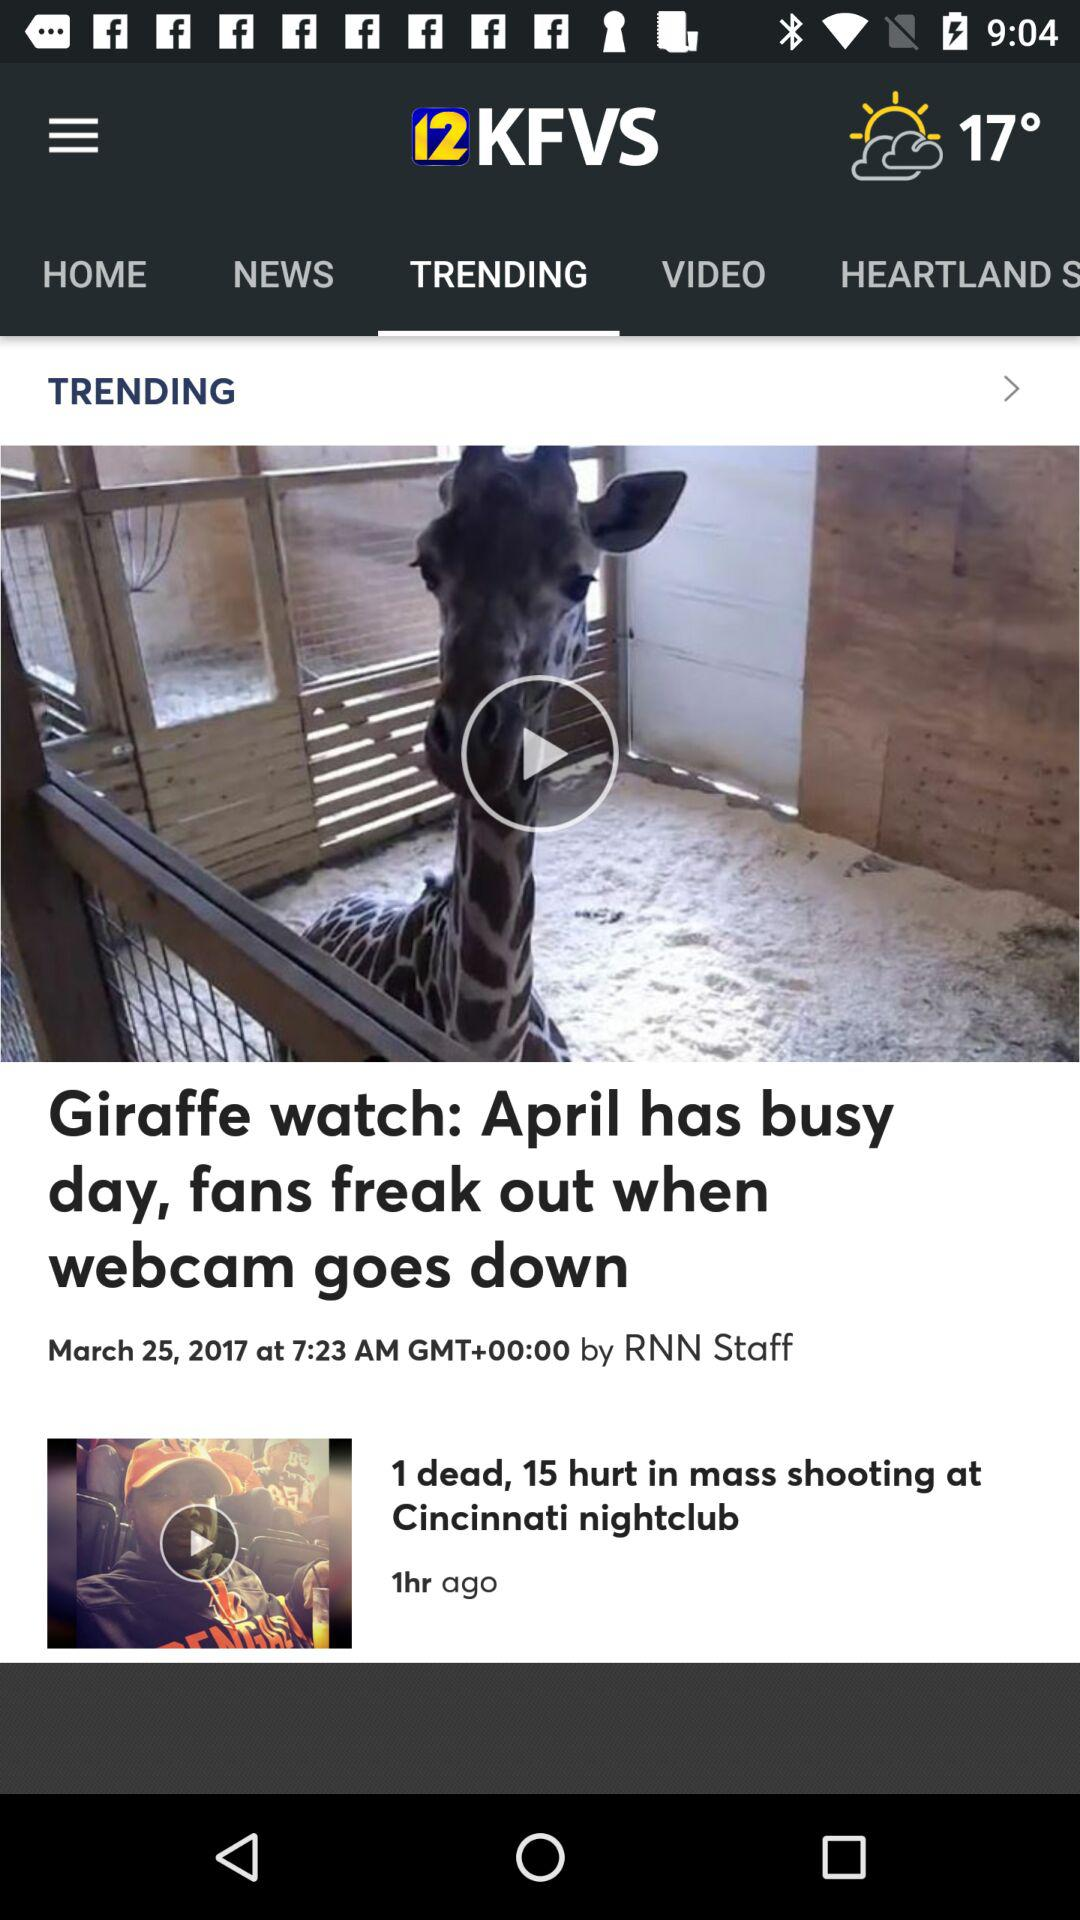Which tab is currently selected? The tab "TRENDING" is currently selected. 